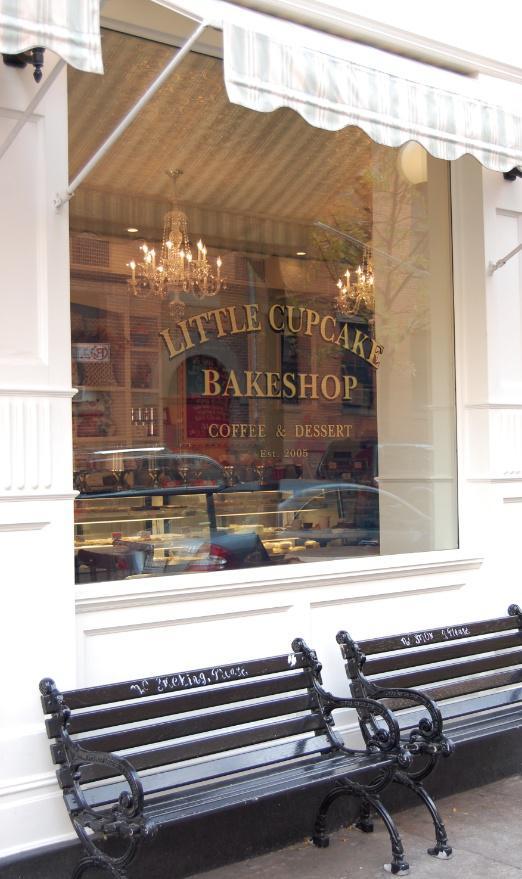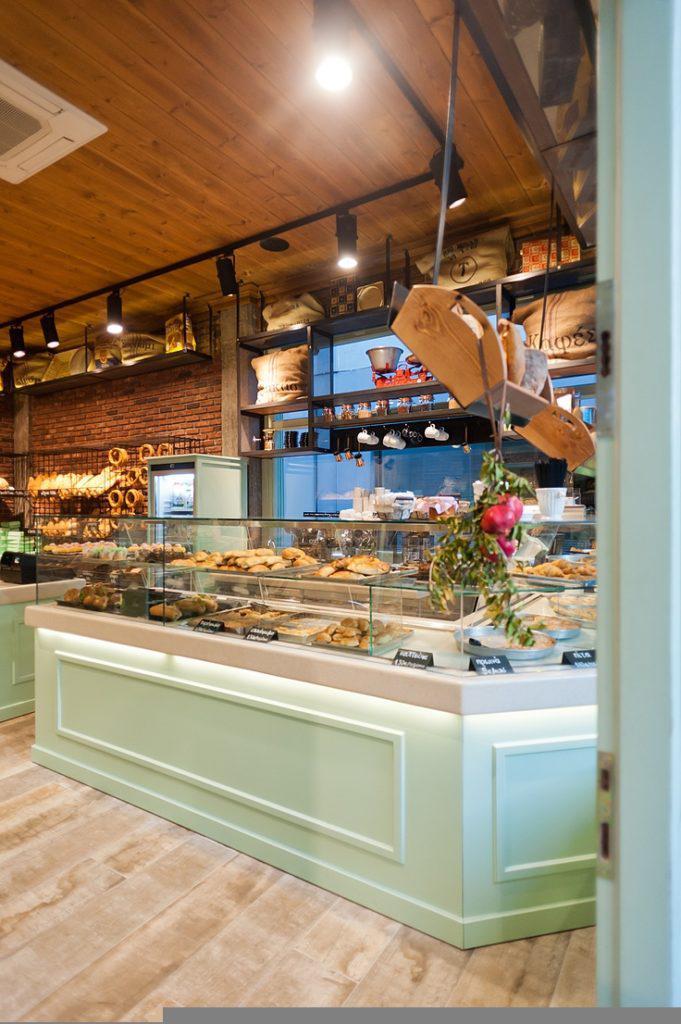The first image is the image on the left, the second image is the image on the right. Analyze the images presented: Is the assertion "In one image, dark wall-mounted menu boards have items listed in white writing." valid? Answer yes or no. No. 